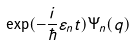Convert formula to latex. <formula><loc_0><loc_0><loc_500><loc_500>\exp ( - \frac { i } { \hbar } { \varepsilon } _ { n } t ) \Psi _ { n } ( { q } )</formula> 